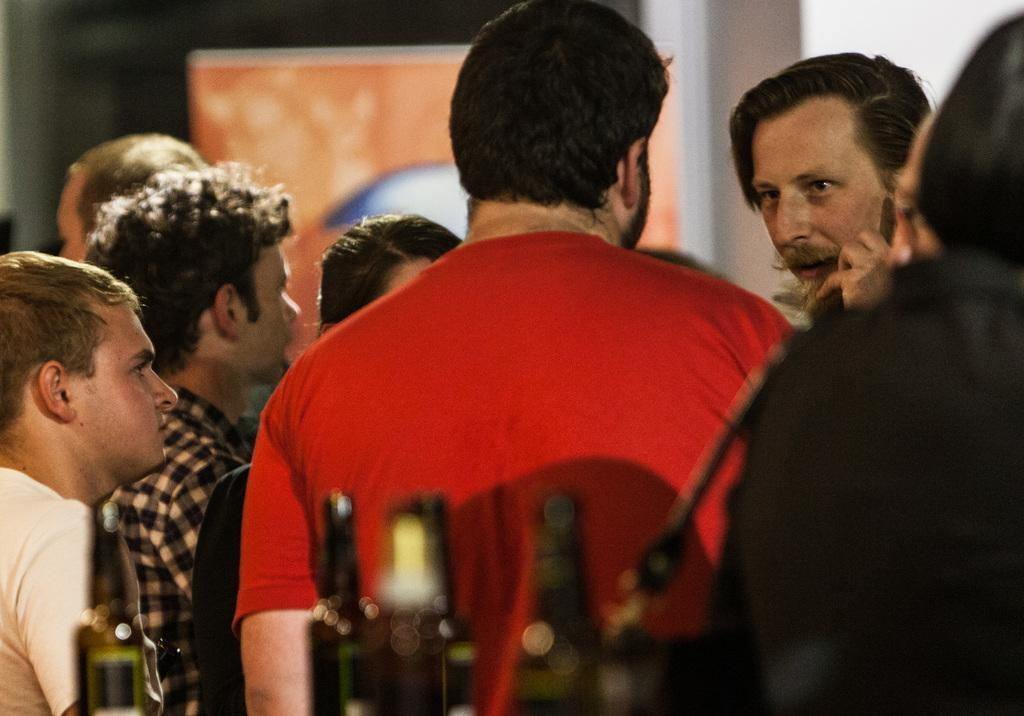In one or two sentences, can you explain what this image depicts? In this image, I can see a group of people standing. At the bottom of the image, I think these are the bottles. In the background, that looks like a poster. 